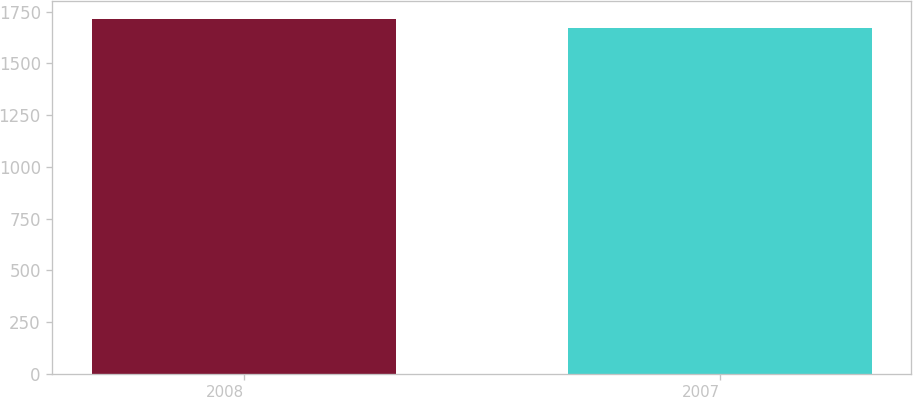Convert chart. <chart><loc_0><loc_0><loc_500><loc_500><bar_chart><fcel>2008<fcel>2007<nl><fcel>1716<fcel>1672<nl></chart> 